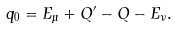<formula> <loc_0><loc_0><loc_500><loc_500>q _ { 0 } = E _ { \mu } + Q ^ { \prime } - Q - E _ { \nu } .</formula> 